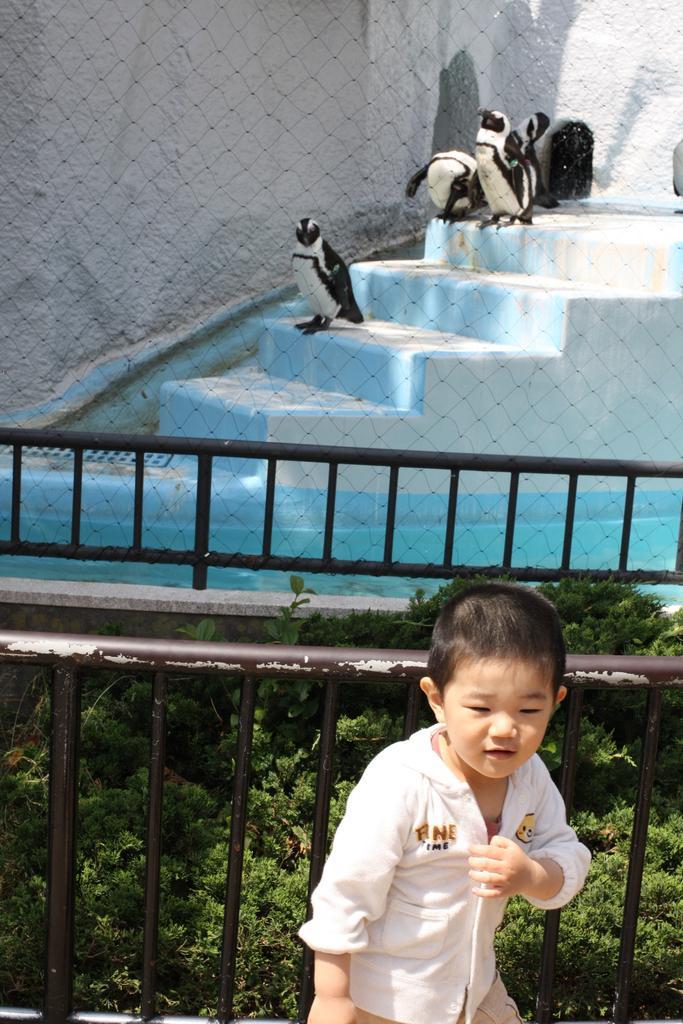How would you summarize this image in a sentence or two? here is a child in a white color shirt. Beside this child, there is an iron fence. Beside this iron fence, there are plants. Beside these plants, there is another iron fence. In the background, there is water, there are penguins on the steps and there is a wall. 